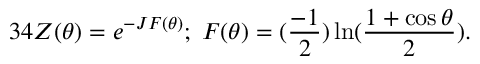Convert formula to latex. <formula><loc_0><loc_0><loc_500><loc_500>3 4 Z ( \theta ) = e ^ { - J F ( \theta ) } ; \, F ( \theta ) = ( \frac { - 1 } { 2 } ) \ln ( \frac { 1 + \cos \theta } { 2 } ) .</formula> 